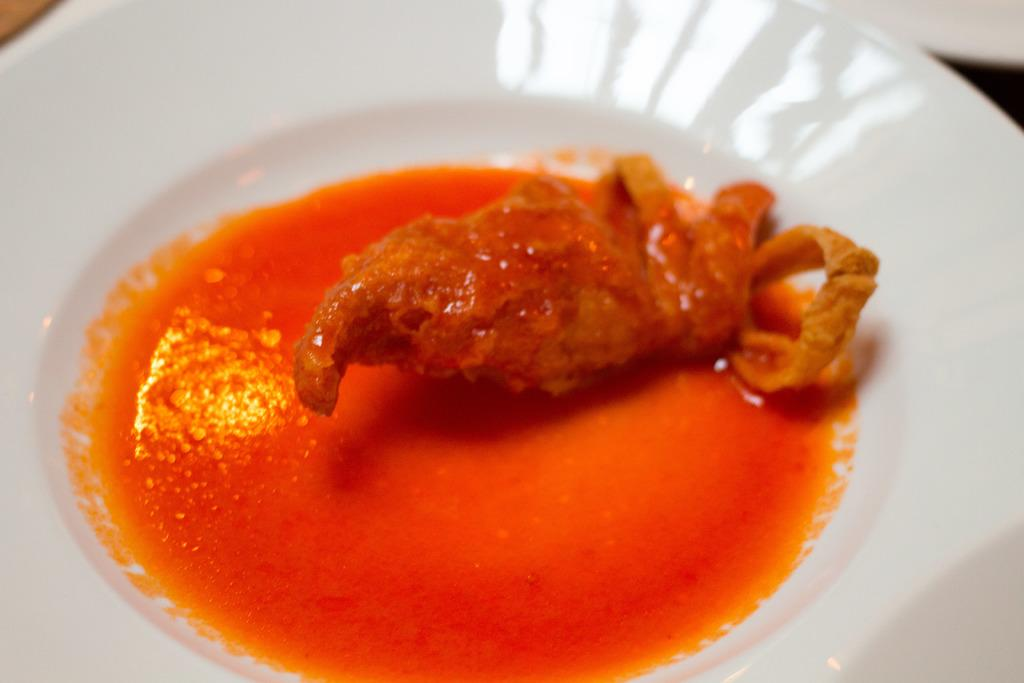What is the main object in the center of the image? There is a plate in the center of the image. What is on the plate? The plate contains chipirones rellenos. Are there any children playing with popcorn in the image? There is no reference to children or popcorn in the image; it only features a plate with chipirones rellenos. 